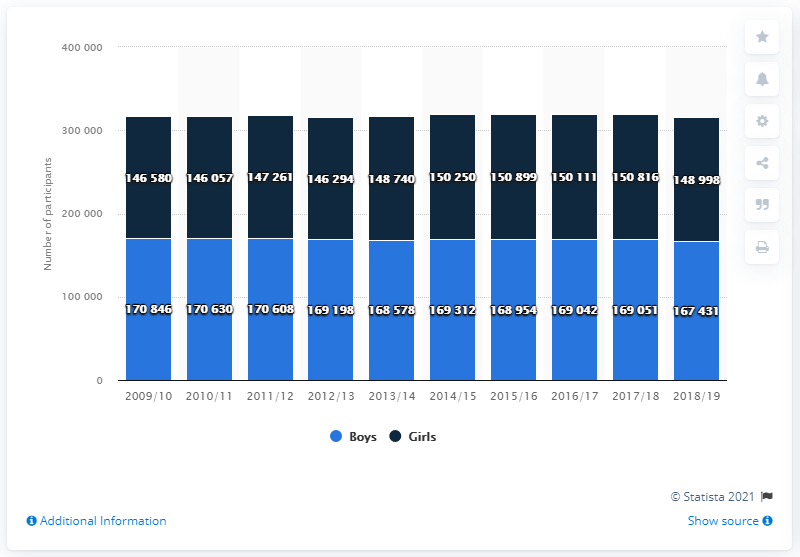Highlight a few significant elements in this photo. In the 2018/2019 school year, a total of 167,431 boys participated in high school sports. 